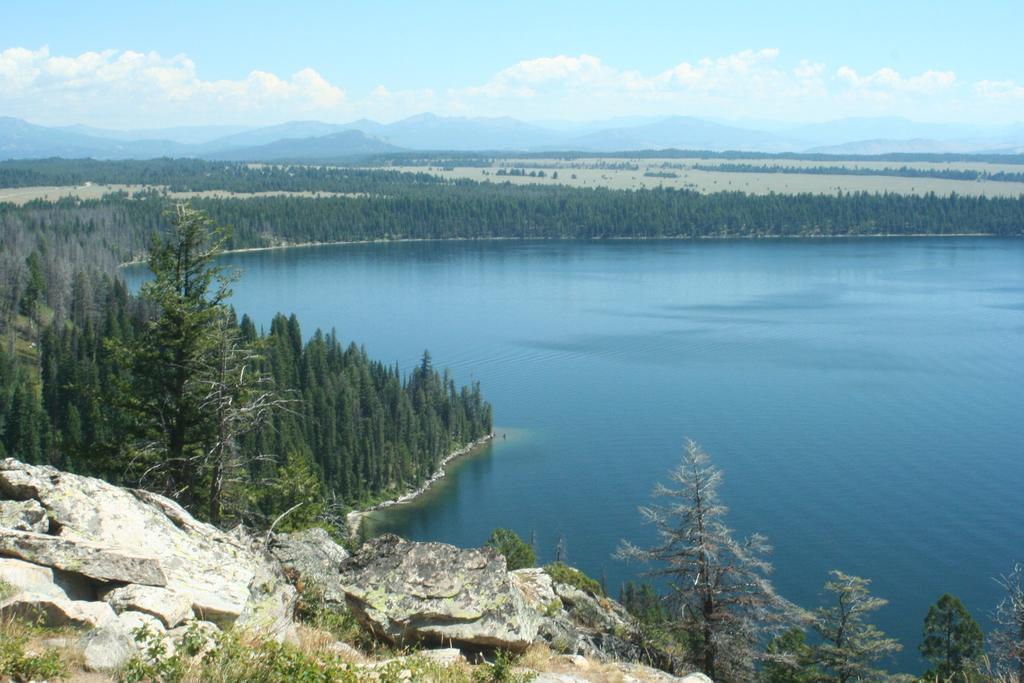Can you describe this image briefly? In this picture I can see the lake. At the bottom I can see the grass and stones. In the background I can see many trees, plants and mountains. At the top I can see the sky and clouds. 